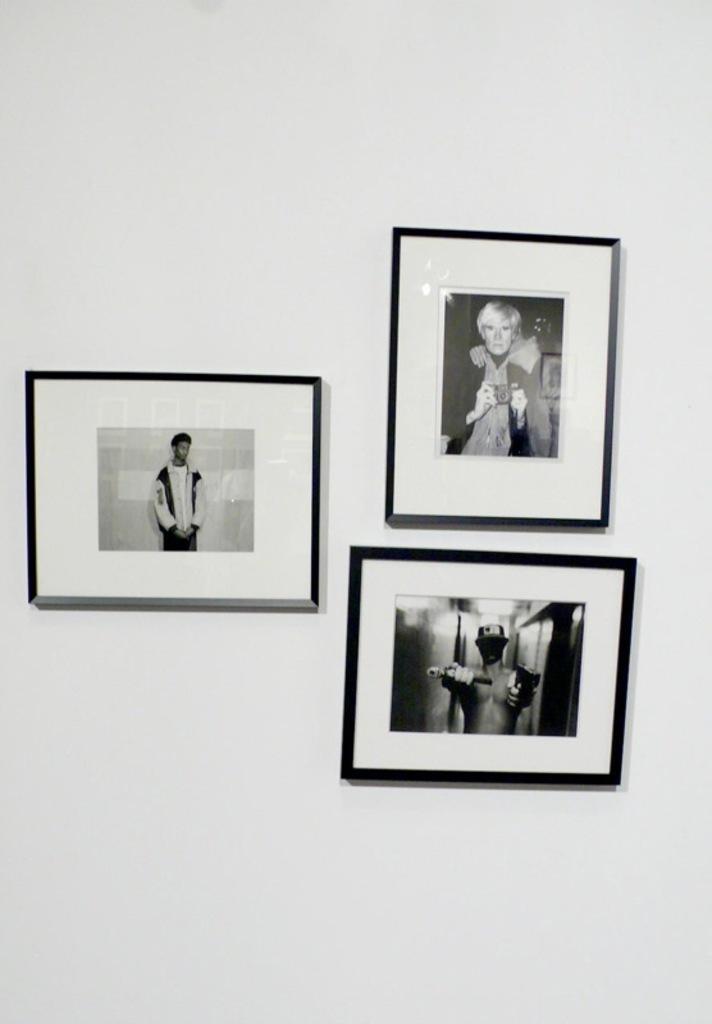Describe this image in one or two sentences. In the image there are three different photo frames attached to a white background. 